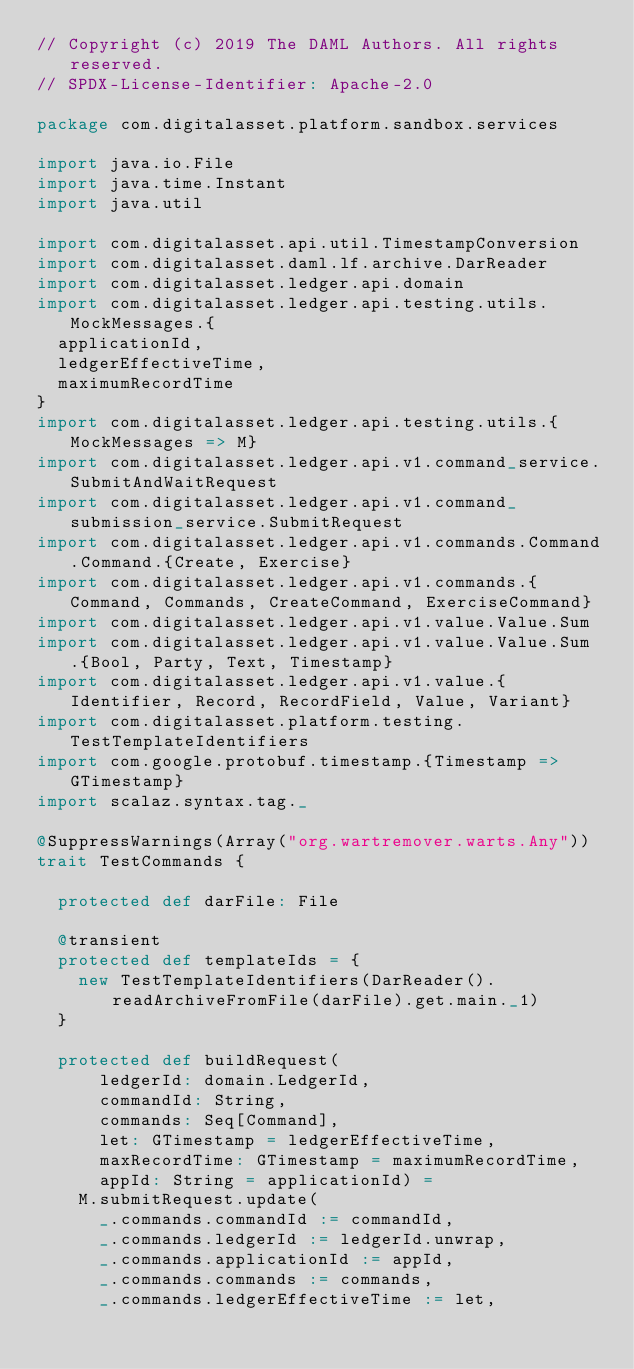<code> <loc_0><loc_0><loc_500><loc_500><_Scala_>// Copyright (c) 2019 The DAML Authors. All rights reserved.
// SPDX-License-Identifier: Apache-2.0

package com.digitalasset.platform.sandbox.services

import java.io.File
import java.time.Instant
import java.util

import com.digitalasset.api.util.TimestampConversion
import com.digitalasset.daml.lf.archive.DarReader
import com.digitalasset.ledger.api.domain
import com.digitalasset.ledger.api.testing.utils.MockMessages.{
  applicationId,
  ledgerEffectiveTime,
  maximumRecordTime
}
import com.digitalasset.ledger.api.testing.utils.{MockMessages => M}
import com.digitalasset.ledger.api.v1.command_service.SubmitAndWaitRequest
import com.digitalasset.ledger.api.v1.command_submission_service.SubmitRequest
import com.digitalasset.ledger.api.v1.commands.Command.Command.{Create, Exercise}
import com.digitalasset.ledger.api.v1.commands.{Command, Commands, CreateCommand, ExerciseCommand}
import com.digitalasset.ledger.api.v1.value.Value.Sum
import com.digitalasset.ledger.api.v1.value.Value.Sum.{Bool, Party, Text, Timestamp}
import com.digitalasset.ledger.api.v1.value.{Identifier, Record, RecordField, Value, Variant}
import com.digitalasset.platform.testing.TestTemplateIdentifiers
import com.google.protobuf.timestamp.{Timestamp => GTimestamp}
import scalaz.syntax.tag._

@SuppressWarnings(Array("org.wartremover.warts.Any"))
trait TestCommands {

  protected def darFile: File

  @transient
  protected def templateIds = {
    new TestTemplateIdentifiers(DarReader().readArchiveFromFile(darFile).get.main._1)
  }

  protected def buildRequest(
      ledgerId: domain.LedgerId,
      commandId: String,
      commands: Seq[Command],
      let: GTimestamp = ledgerEffectiveTime,
      maxRecordTime: GTimestamp = maximumRecordTime,
      appId: String = applicationId) =
    M.submitRequest.update(
      _.commands.commandId := commandId,
      _.commands.ledgerId := ledgerId.unwrap,
      _.commands.applicationId := appId,
      _.commands.commands := commands,
      _.commands.ledgerEffectiveTime := let,</code> 